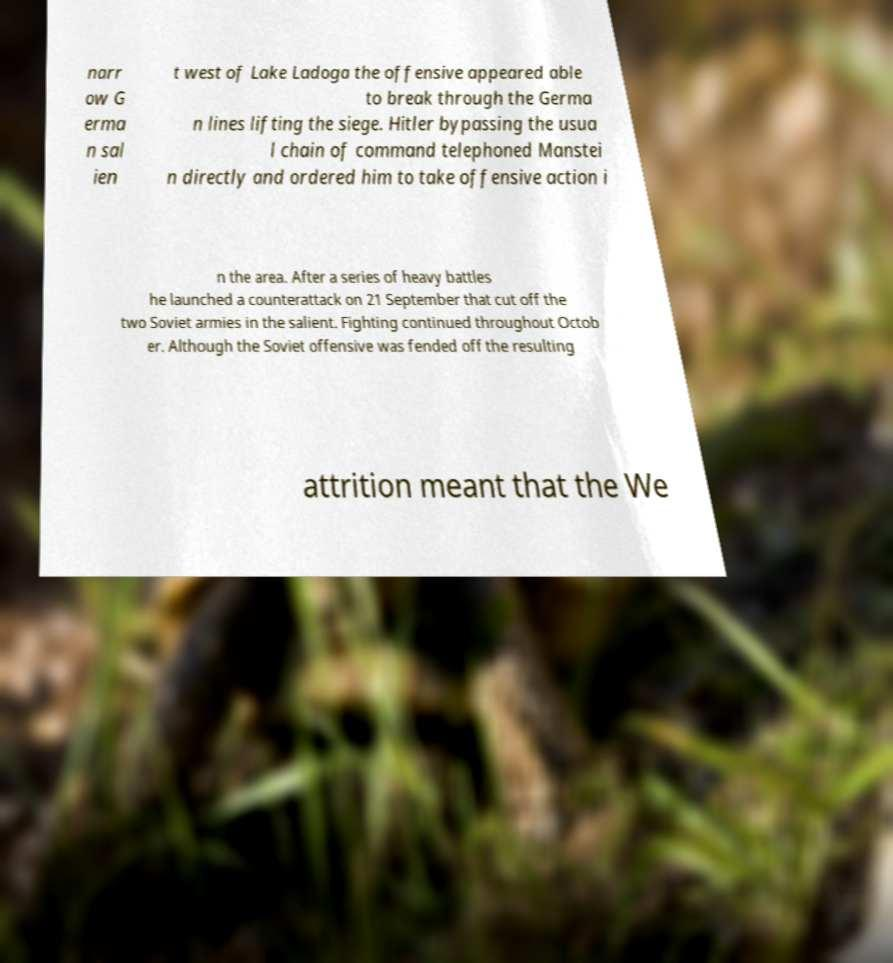There's text embedded in this image that I need extracted. Can you transcribe it verbatim? narr ow G erma n sal ien t west of Lake Ladoga the offensive appeared able to break through the Germa n lines lifting the siege. Hitler bypassing the usua l chain of command telephoned Manstei n directly and ordered him to take offensive action i n the area. After a series of heavy battles he launched a counterattack on 21 September that cut off the two Soviet armies in the salient. Fighting continued throughout Octob er. Although the Soviet offensive was fended off the resulting attrition meant that the We 